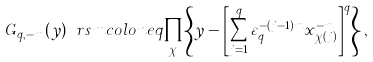Convert formula to latex. <formula><loc_0><loc_0><loc_500><loc_500>G _ { q , - m } ( y ) \ r s m c o l o n e q \prod _ { \chi } \left \{ y - \left [ \sum _ { j = 1 } ^ { q } \varepsilon _ { q } ^ { - ( j - 1 ) m } x _ { \chi ( j ) } ^ { - m } \right ] ^ { q } \right \} ,</formula> 